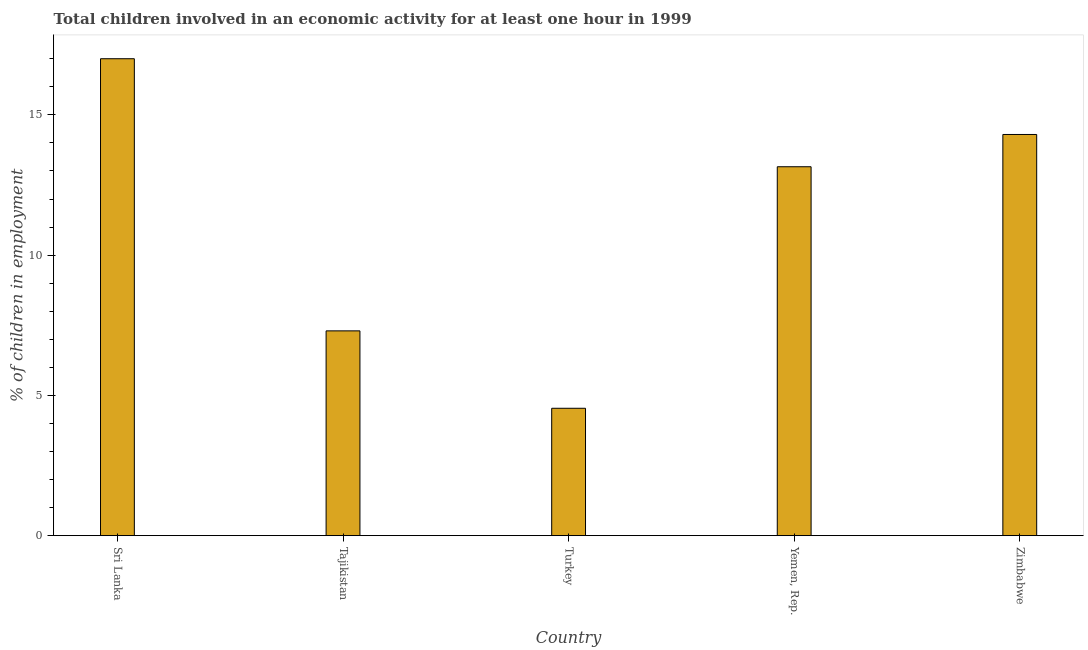Does the graph contain any zero values?
Your answer should be compact. No. What is the title of the graph?
Your answer should be very brief. Total children involved in an economic activity for at least one hour in 1999. What is the label or title of the Y-axis?
Your answer should be compact. % of children in employment. What is the percentage of children in employment in Zimbabwe?
Offer a terse response. 14.3. Across all countries, what is the maximum percentage of children in employment?
Keep it short and to the point. 17. Across all countries, what is the minimum percentage of children in employment?
Provide a succinct answer. 4.54. In which country was the percentage of children in employment maximum?
Ensure brevity in your answer.  Sri Lanka. In which country was the percentage of children in employment minimum?
Provide a succinct answer. Turkey. What is the sum of the percentage of children in employment?
Offer a terse response. 56.29. What is the difference between the percentage of children in employment in Tajikistan and Turkey?
Provide a succinct answer. 2.76. What is the average percentage of children in employment per country?
Your response must be concise. 11.26. What is the median percentage of children in employment?
Offer a very short reply. 13.15. What is the ratio of the percentage of children in employment in Turkey to that in Zimbabwe?
Offer a very short reply. 0.32. What is the difference between the highest and the lowest percentage of children in employment?
Your answer should be compact. 12.46. How many bars are there?
Offer a terse response. 5. Are all the bars in the graph horizontal?
Offer a very short reply. No. How many countries are there in the graph?
Your answer should be very brief. 5. What is the difference between two consecutive major ticks on the Y-axis?
Your response must be concise. 5. Are the values on the major ticks of Y-axis written in scientific E-notation?
Offer a terse response. No. What is the % of children in employment of Turkey?
Your response must be concise. 4.54. What is the % of children in employment in Yemen, Rep.?
Provide a short and direct response. 13.15. What is the % of children in employment of Zimbabwe?
Provide a short and direct response. 14.3. What is the difference between the % of children in employment in Sri Lanka and Turkey?
Your answer should be very brief. 12.46. What is the difference between the % of children in employment in Sri Lanka and Yemen, Rep.?
Keep it short and to the point. 3.85. What is the difference between the % of children in employment in Tajikistan and Turkey?
Make the answer very short. 2.76. What is the difference between the % of children in employment in Tajikistan and Yemen, Rep.?
Your response must be concise. -5.85. What is the difference between the % of children in employment in Turkey and Yemen, Rep.?
Give a very brief answer. -8.61. What is the difference between the % of children in employment in Turkey and Zimbabwe?
Your answer should be very brief. -9.76. What is the difference between the % of children in employment in Yemen, Rep. and Zimbabwe?
Your answer should be compact. -1.15. What is the ratio of the % of children in employment in Sri Lanka to that in Tajikistan?
Make the answer very short. 2.33. What is the ratio of the % of children in employment in Sri Lanka to that in Turkey?
Provide a short and direct response. 3.74. What is the ratio of the % of children in employment in Sri Lanka to that in Yemen, Rep.?
Make the answer very short. 1.29. What is the ratio of the % of children in employment in Sri Lanka to that in Zimbabwe?
Your answer should be very brief. 1.19. What is the ratio of the % of children in employment in Tajikistan to that in Turkey?
Your answer should be very brief. 1.61. What is the ratio of the % of children in employment in Tajikistan to that in Yemen, Rep.?
Make the answer very short. 0.56. What is the ratio of the % of children in employment in Tajikistan to that in Zimbabwe?
Provide a short and direct response. 0.51. What is the ratio of the % of children in employment in Turkey to that in Yemen, Rep.?
Offer a very short reply. 0.34. What is the ratio of the % of children in employment in Turkey to that in Zimbabwe?
Your answer should be very brief. 0.32. What is the ratio of the % of children in employment in Yemen, Rep. to that in Zimbabwe?
Give a very brief answer. 0.92. 